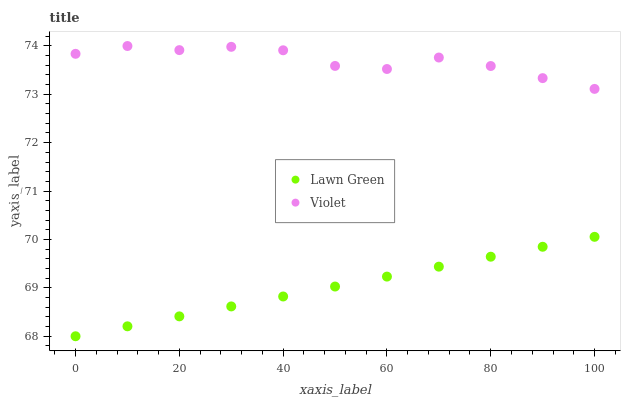Does Lawn Green have the minimum area under the curve?
Answer yes or no. Yes. Does Violet have the maximum area under the curve?
Answer yes or no. Yes. Does Violet have the minimum area under the curve?
Answer yes or no. No. Is Lawn Green the smoothest?
Answer yes or no. Yes. Is Violet the roughest?
Answer yes or no. Yes. Is Violet the smoothest?
Answer yes or no. No. Does Lawn Green have the lowest value?
Answer yes or no. Yes. Does Violet have the lowest value?
Answer yes or no. No. Does Violet have the highest value?
Answer yes or no. Yes. Is Lawn Green less than Violet?
Answer yes or no. Yes. Is Violet greater than Lawn Green?
Answer yes or no. Yes. Does Lawn Green intersect Violet?
Answer yes or no. No. 